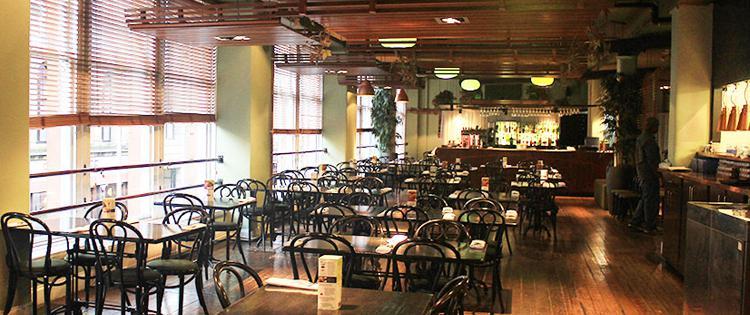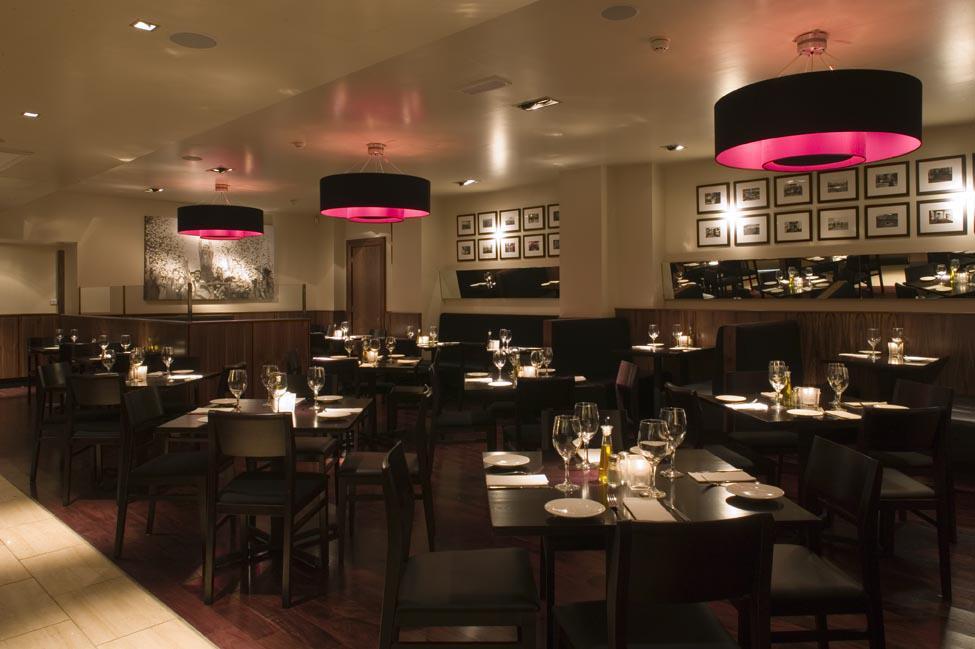The first image is the image on the left, the second image is the image on the right. Analyze the images presented: Is the assertion "One restaurant interior features multiple cyclindrical black and red suspended lights over the seating area." valid? Answer yes or no. Yes. The first image is the image on the left, the second image is the image on the right. Considering the images on both sides, is "there is a painted tray ceiling with lighting hanging from it" valid? Answer yes or no. No. 